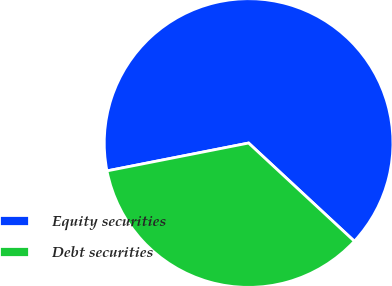Convert chart. <chart><loc_0><loc_0><loc_500><loc_500><pie_chart><fcel>Equity securities<fcel>Debt securities<nl><fcel>65.0%<fcel>35.0%<nl></chart> 